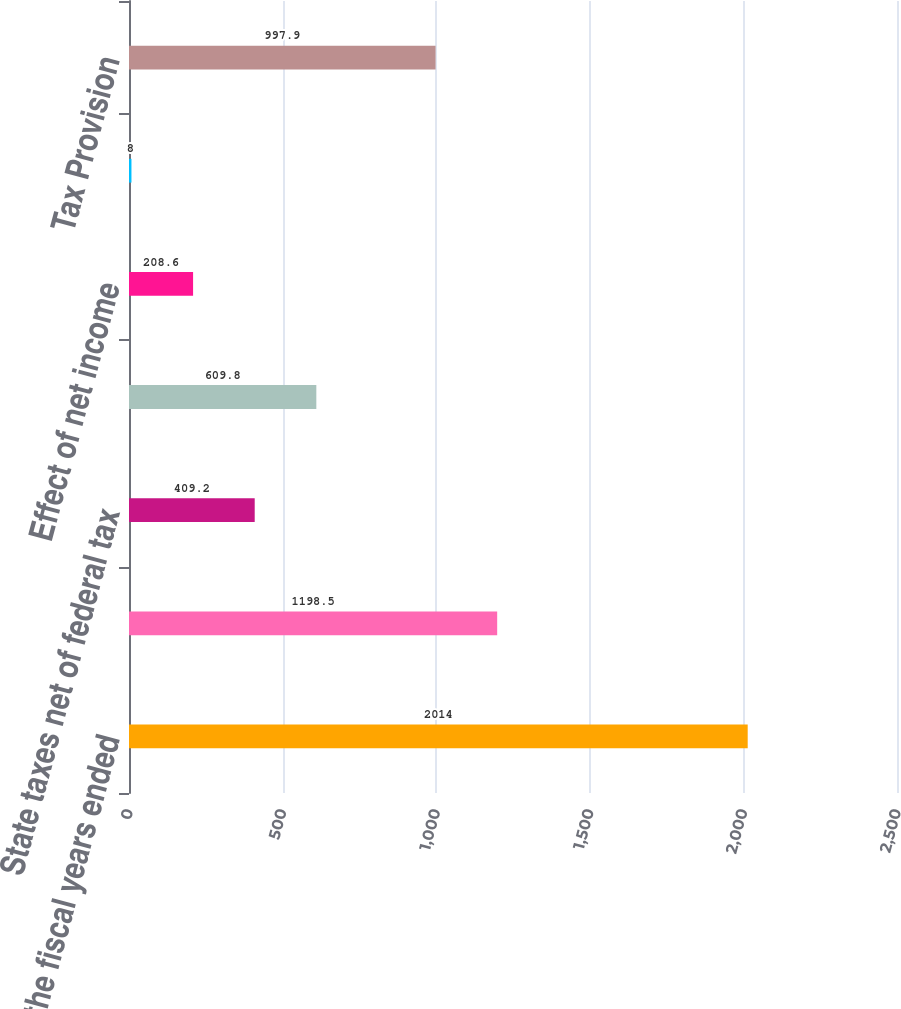Convert chart. <chart><loc_0><loc_0><loc_500><loc_500><bar_chart><fcel>for the fiscal years ended<fcel>Federal taxes at statutory<fcel>State taxes net of federal tax<fcel>Effect of non-US operations<fcel>Effect of net income<fcel>Other<fcel>Tax Provision<nl><fcel>2014<fcel>1198.5<fcel>409.2<fcel>609.8<fcel>208.6<fcel>8<fcel>997.9<nl></chart> 